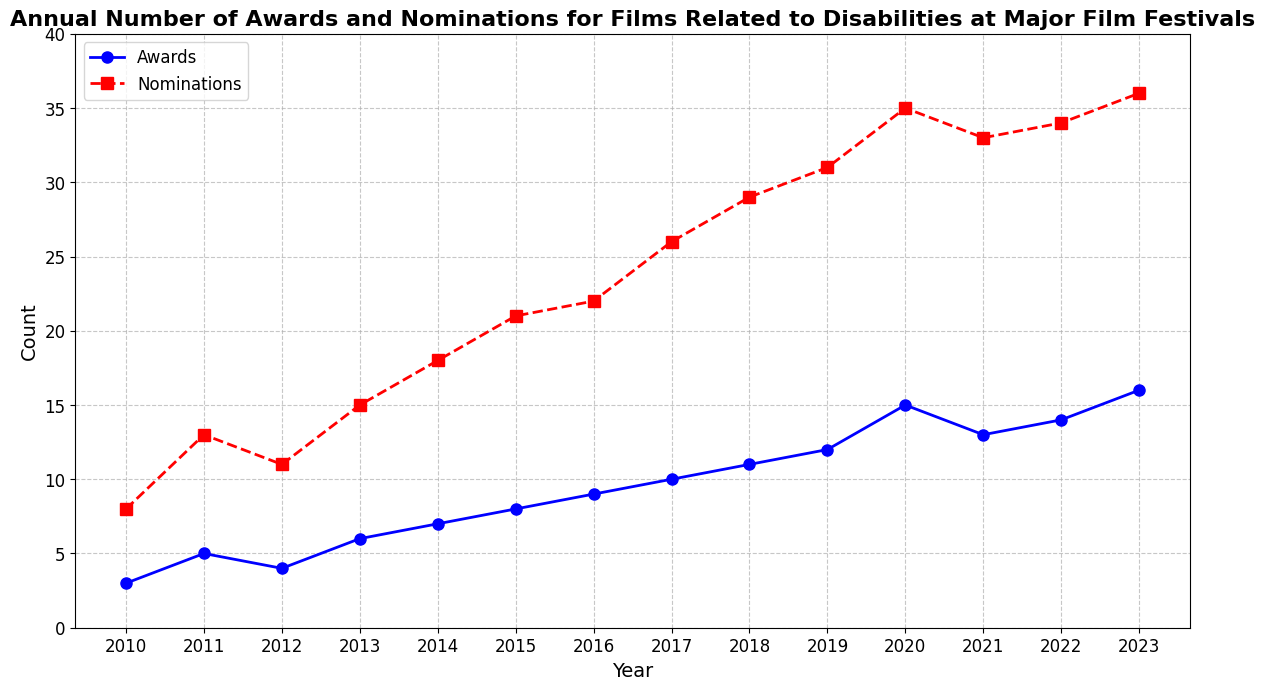What year had both the highest number of awards and nominations? To find the year with both the highest number of awards and nominations, look for the highest data points on both the blue 'Awards' and red 'Nominations' lines. Both peaks occur in the year 2023.
Answer: 2023 How many more nominations were there than awards in 2020? Subtract the number of awards from the number of nominations for the year 2020. Nominations in 2020 are 35, and awards are 15. Therefore, 35 - 15 = 20.
Answer: 20 Between which years did the number of awards increase the most? Look for the greatest increase in the 'Awards' line by calculating the difference between successive years. The largest increase is between 2019 (12) and 2020 (15), which is an increase of 3 awards.
Answer: 2019 and 2020 What is the average number of nominations from 2018 to 2020? Add the number of nominations for the years 2018, 2019, and 2020 and then divide by 3. The numbers are 29, 31, and 35. So, (29 + 31 + 35) / 3 = 31.67.
Answer: 31.67 By how much did the number of awards increase from 2010 to 2023? Subtract the number of awards in 2010 from the number of awards in 2023. Awards in 2023 are 16, and awards in 2010 are 3. Therefore, 16 - 3 = 13.
Answer: 13 Which year had the steepest increase in nominations? Calculate the year-by-year increase in nominations and find the largest value. The steepest increase is from 2017 (26) to 2018 (29), which is 29 - 26 = 3.
Answer: 2017 to 2018 In which years did the number of awards exceed the number of nominations by a ratio of at least half? To find the years where awards are at least half the number of nominations, compare each year's awards with half that year's nominations. This occurs in 2016 (9 awards, 22/2 = 11), 2020 (15 awards, 35/2 = 17.5), 2021 (13 awards, 33/2 = 16.5), 2022 (14 awards, 34/2 = 17), and 2023 (16 awards, 36/2 = 18).
Answer: 2020, 2021, 2022, 2023 How does the number of awards in 2015 compare to the number of nominations in the same year? Locate the data points for awards and nominations in 2015. The number of awards is 8 and the number of nominations is 21. Thus, 8 awards are significantly less than 21 nominations.
Answer: Less What is the trend observed in the number of awards from 2010 to 2023? Observe the overall direction of the 'Awards' line from 2010 to 2023. The number of awards increases steadily over the years, indicating an upward trend.
Answer: Upward trend Which year saw a decrease in both the number of awards and nominations? Locate any year where both the 'Awards' and 'Nominations' lines show a downward slope. Between 2020 and 2021, both awards (15 to 13) and nominations (35 to 33) decreased.
Answer: 2021 